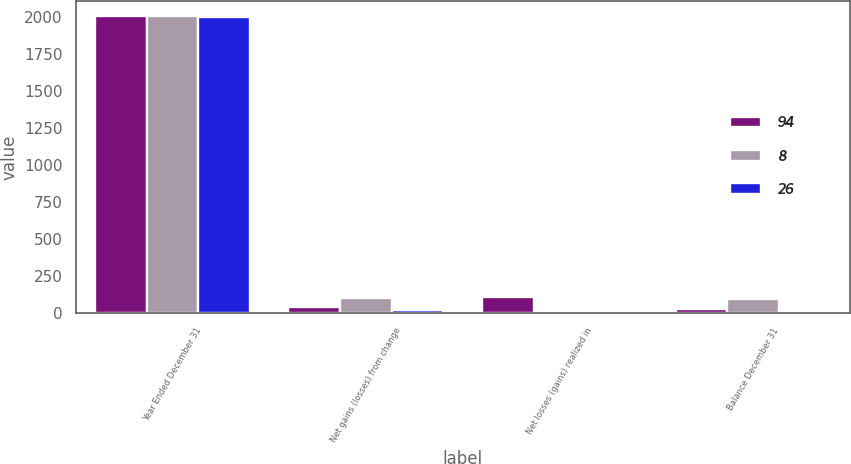Convert chart. <chart><loc_0><loc_0><loc_500><loc_500><stacked_bar_chart><ecel><fcel>Year Ended December 31<fcel>Net gains (losses) from change<fcel>Net losses (gains) realized in<fcel>Balance December 31<nl><fcel>94<fcel>2008<fcel>41<fcel>109<fcel>26<nl><fcel>8<fcel>2007<fcel>101<fcel>1<fcel>94<nl><fcel>26<fcel>2006<fcel>19<fcel>11<fcel>8<nl></chart> 